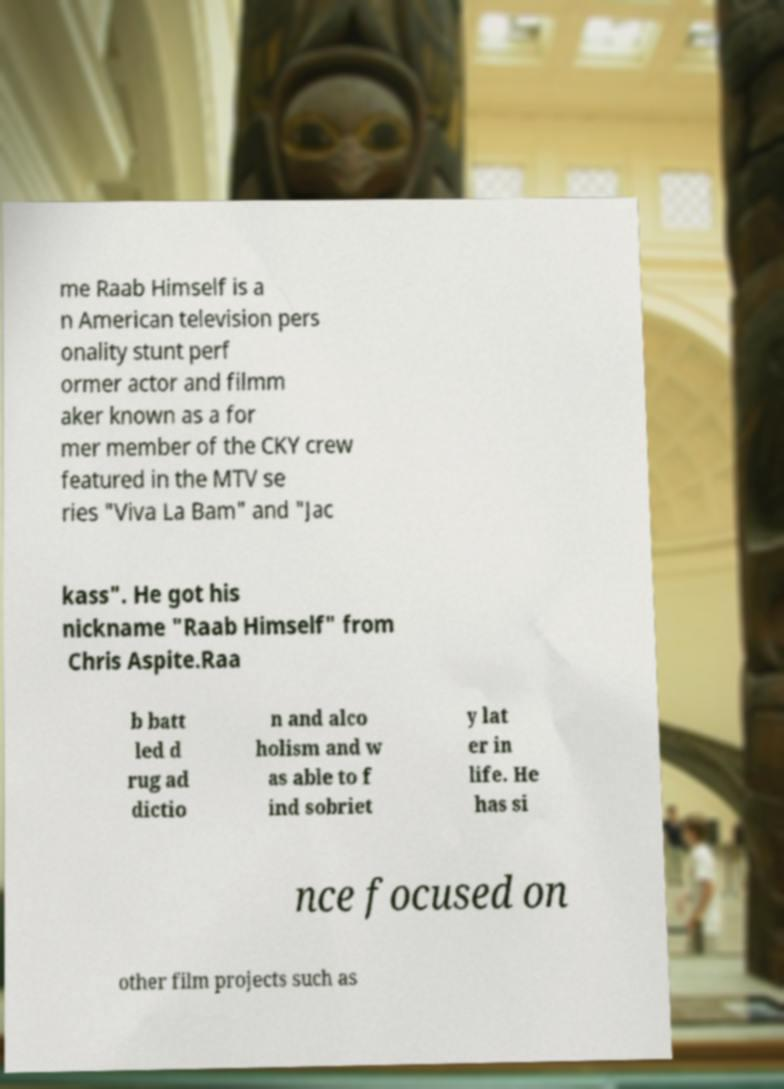Can you accurately transcribe the text from the provided image for me? me Raab Himself is a n American television pers onality stunt perf ormer actor and filmm aker known as a for mer member of the CKY crew featured in the MTV se ries "Viva La Bam" and "Jac kass". He got his nickname "Raab Himself" from Chris Aspite.Raa b batt led d rug ad dictio n and alco holism and w as able to f ind sobriet y lat er in life. He has si nce focused on other film projects such as 